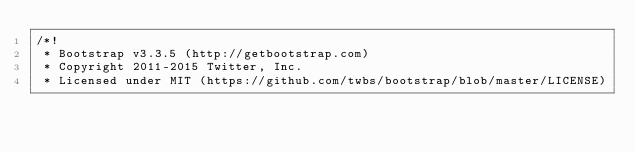Convert code to text. <code><loc_0><loc_0><loc_500><loc_500><_CSS_>/*!
 * Bootstrap v3.3.5 (http://getbootstrap.com)
 * Copyright 2011-2015 Twitter, Inc.
 * Licensed under MIT (https://github.com/twbs/bootstrap/blob/master/LICENSE)</code> 